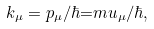<formula> <loc_0><loc_0><loc_500><loc_500>k _ { \mu } = p _ { \mu } / \hbar { = } m u _ { \mu } / \hbar { , }</formula> 